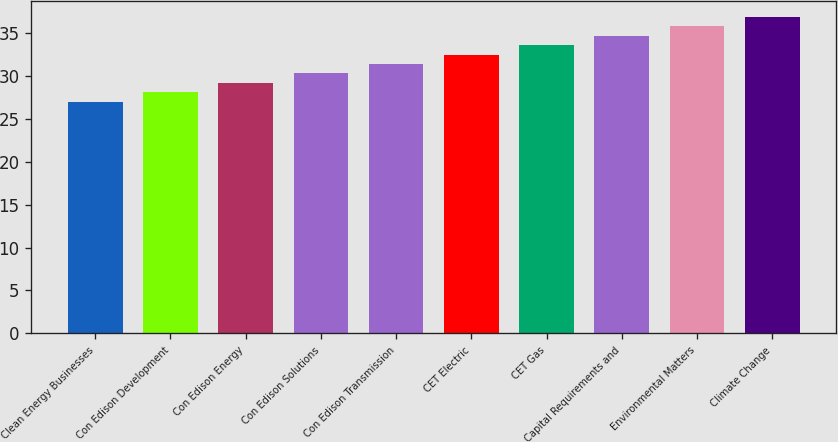Convert chart. <chart><loc_0><loc_0><loc_500><loc_500><bar_chart><fcel>Clean Energy Businesses<fcel>Con Edison Development<fcel>Con Edison Energy<fcel>Con Edison Solutions<fcel>Con Edison Transmission<fcel>CET Electric<fcel>CET Gas<fcel>Capital Requirements and<fcel>Environmental Matters<fcel>Climate Change<nl><fcel>27<fcel>28.1<fcel>29.2<fcel>30.3<fcel>31.4<fcel>32.5<fcel>33.6<fcel>34.7<fcel>35.8<fcel>36.9<nl></chart> 